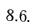<formula> <loc_0><loc_0><loc_500><loc_500>8 . 6 .</formula> 